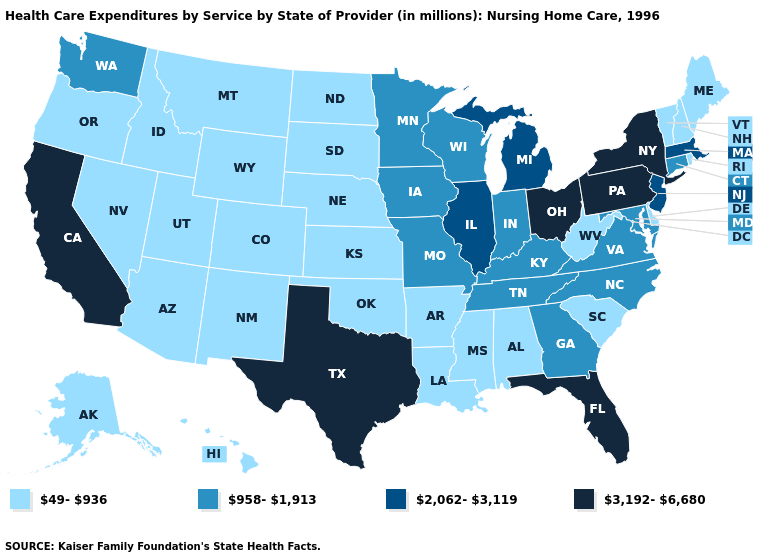Does North Carolina have the highest value in the South?
Write a very short answer. No. Name the states that have a value in the range 49-936?
Keep it brief. Alabama, Alaska, Arizona, Arkansas, Colorado, Delaware, Hawaii, Idaho, Kansas, Louisiana, Maine, Mississippi, Montana, Nebraska, Nevada, New Hampshire, New Mexico, North Dakota, Oklahoma, Oregon, Rhode Island, South Carolina, South Dakota, Utah, Vermont, West Virginia, Wyoming. What is the value of Kansas?
Concise answer only. 49-936. What is the highest value in states that border Virginia?
Keep it brief. 958-1,913. What is the lowest value in the MidWest?
Answer briefly. 49-936. Is the legend a continuous bar?
Give a very brief answer. No. What is the value of Ohio?
Keep it brief. 3,192-6,680. What is the value of Wyoming?
Write a very short answer. 49-936. Name the states that have a value in the range 2,062-3,119?
Quick response, please. Illinois, Massachusetts, Michigan, New Jersey. Does Washington have the lowest value in the West?
Quick response, please. No. What is the value of Indiana?
Concise answer only. 958-1,913. Which states hav the highest value in the MidWest?
Give a very brief answer. Ohio. What is the lowest value in states that border New Jersey?
Concise answer only. 49-936. What is the value of North Carolina?
Give a very brief answer. 958-1,913. What is the highest value in the West ?
Answer briefly. 3,192-6,680. 